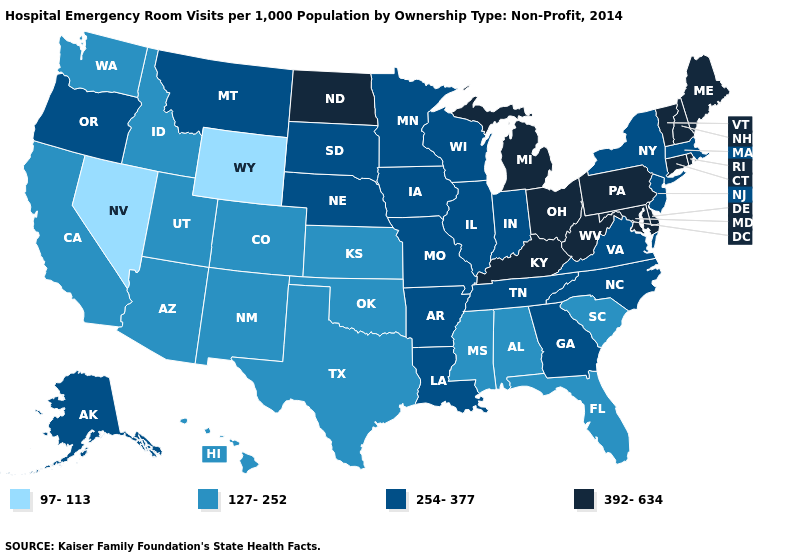Name the states that have a value in the range 392-634?
Concise answer only. Connecticut, Delaware, Kentucky, Maine, Maryland, Michigan, New Hampshire, North Dakota, Ohio, Pennsylvania, Rhode Island, Vermont, West Virginia. Name the states that have a value in the range 254-377?
Write a very short answer. Alaska, Arkansas, Georgia, Illinois, Indiana, Iowa, Louisiana, Massachusetts, Minnesota, Missouri, Montana, Nebraska, New Jersey, New York, North Carolina, Oregon, South Dakota, Tennessee, Virginia, Wisconsin. Which states have the lowest value in the USA?
Be succinct. Nevada, Wyoming. What is the lowest value in states that border Idaho?
Be succinct. 97-113. What is the value of New York?
Keep it brief. 254-377. Does South Dakota have the highest value in the MidWest?
Answer briefly. No. Name the states that have a value in the range 127-252?
Answer briefly. Alabama, Arizona, California, Colorado, Florida, Hawaii, Idaho, Kansas, Mississippi, New Mexico, Oklahoma, South Carolina, Texas, Utah, Washington. What is the value of Delaware?
Be succinct. 392-634. Does the map have missing data?
Give a very brief answer. No. What is the value of West Virginia?
Give a very brief answer. 392-634. Does Illinois have the lowest value in the USA?
Concise answer only. No. What is the lowest value in the MidWest?
Be succinct. 127-252. What is the lowest value in the Northeast?
Write a very short answer. 254-377. Name the states that have a value in the range 127-252?
Short answer required. Alabama, Arizona, California, Colorado, Florida, Hawaii, Idaho, Kansas, Mississippi, New Mexico, Oklahoma, South Carolina, Texas, Utah, Washington. Which states hav the highest value in the MidWest?
Keep it brief. Michigan, North Dakota, Ohio. 